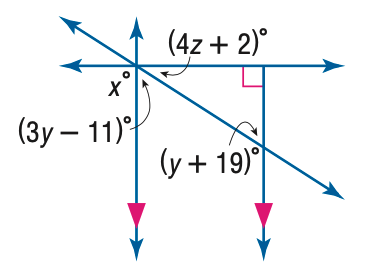Answer the mathemtical geometry problem and directly provide the correct option letter.
Question: Find z in the figure.
Choices: A: 13.5 B: 14 C: 14.5 D: 15 A 